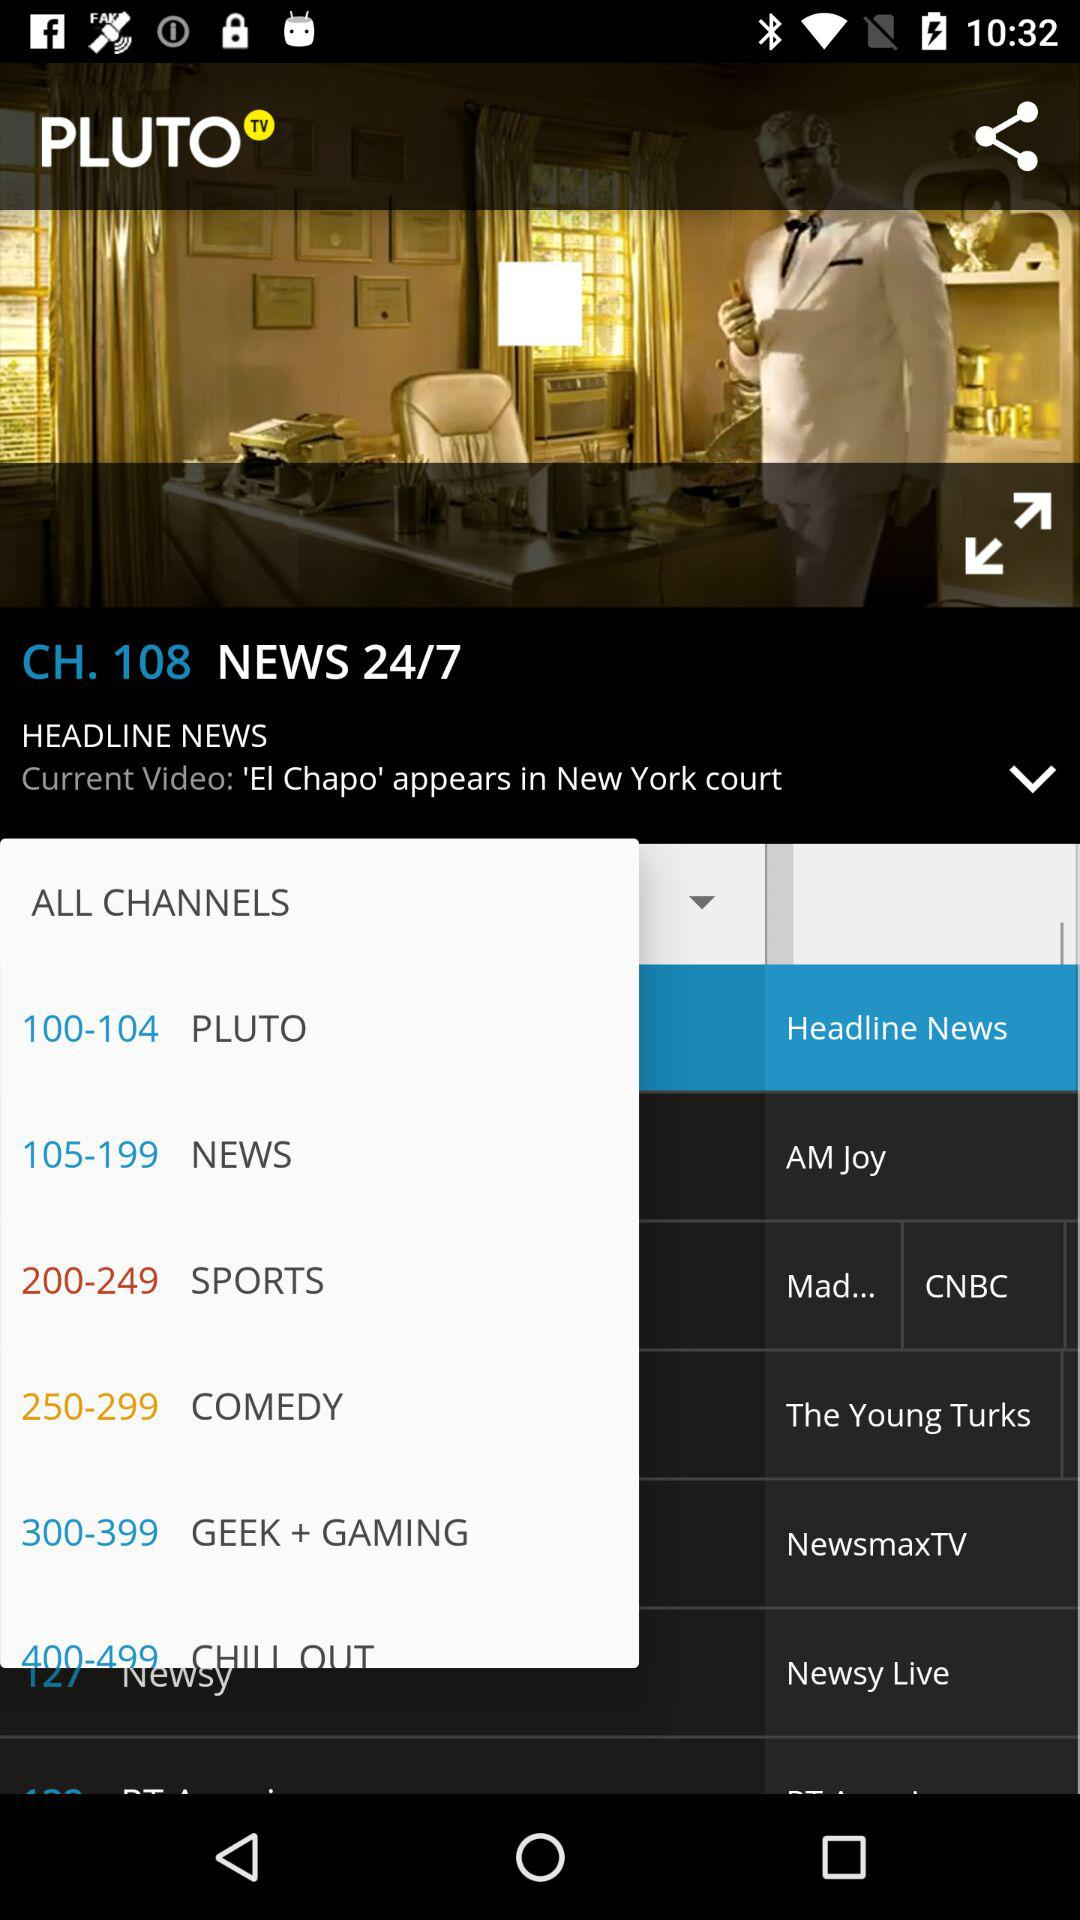What is the channel number for "NEWS 24/7"? The channel number is 108. 